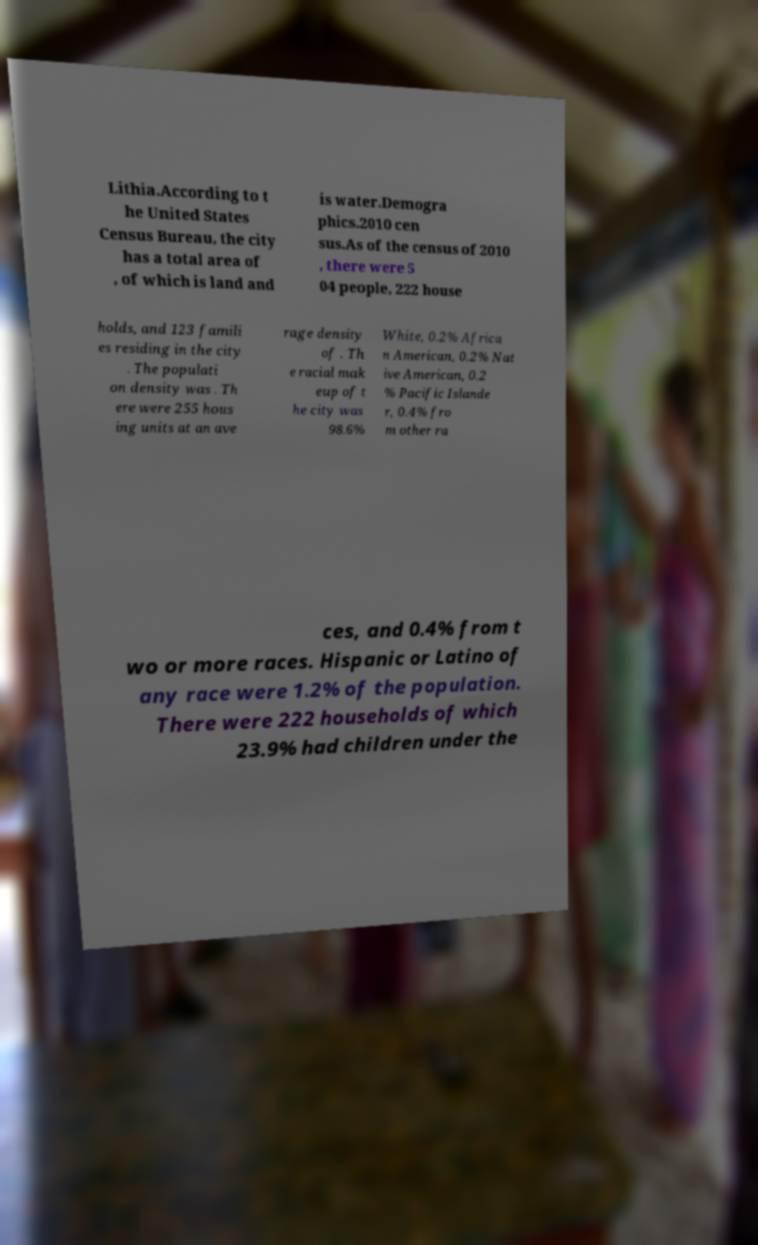I need the written content from this picture converted into text. Can you do that? Lithia.According to t he United States Census Bureau, the city has a total area of , of which is land and is water.Demogra phics.2010 cen sus.As of the census of 2010 , there were 5 04 people, 222 house holds, and 123 famili es residing in the city . The populati on density was . Th ere were 255 hous ing units at an ave rage density of . Th e racial mak eup of t he city was 98.6% White, 0.2% Africa n American, 0.2% Nat ive American, 0.2 % Pacific Islande r, 0.4% fro m other ra ces, and 0.4% from t wo or more races. Hispanic or Latino of any race were 1.2% of the population. There were 222 households of which 23.9% had children under the 